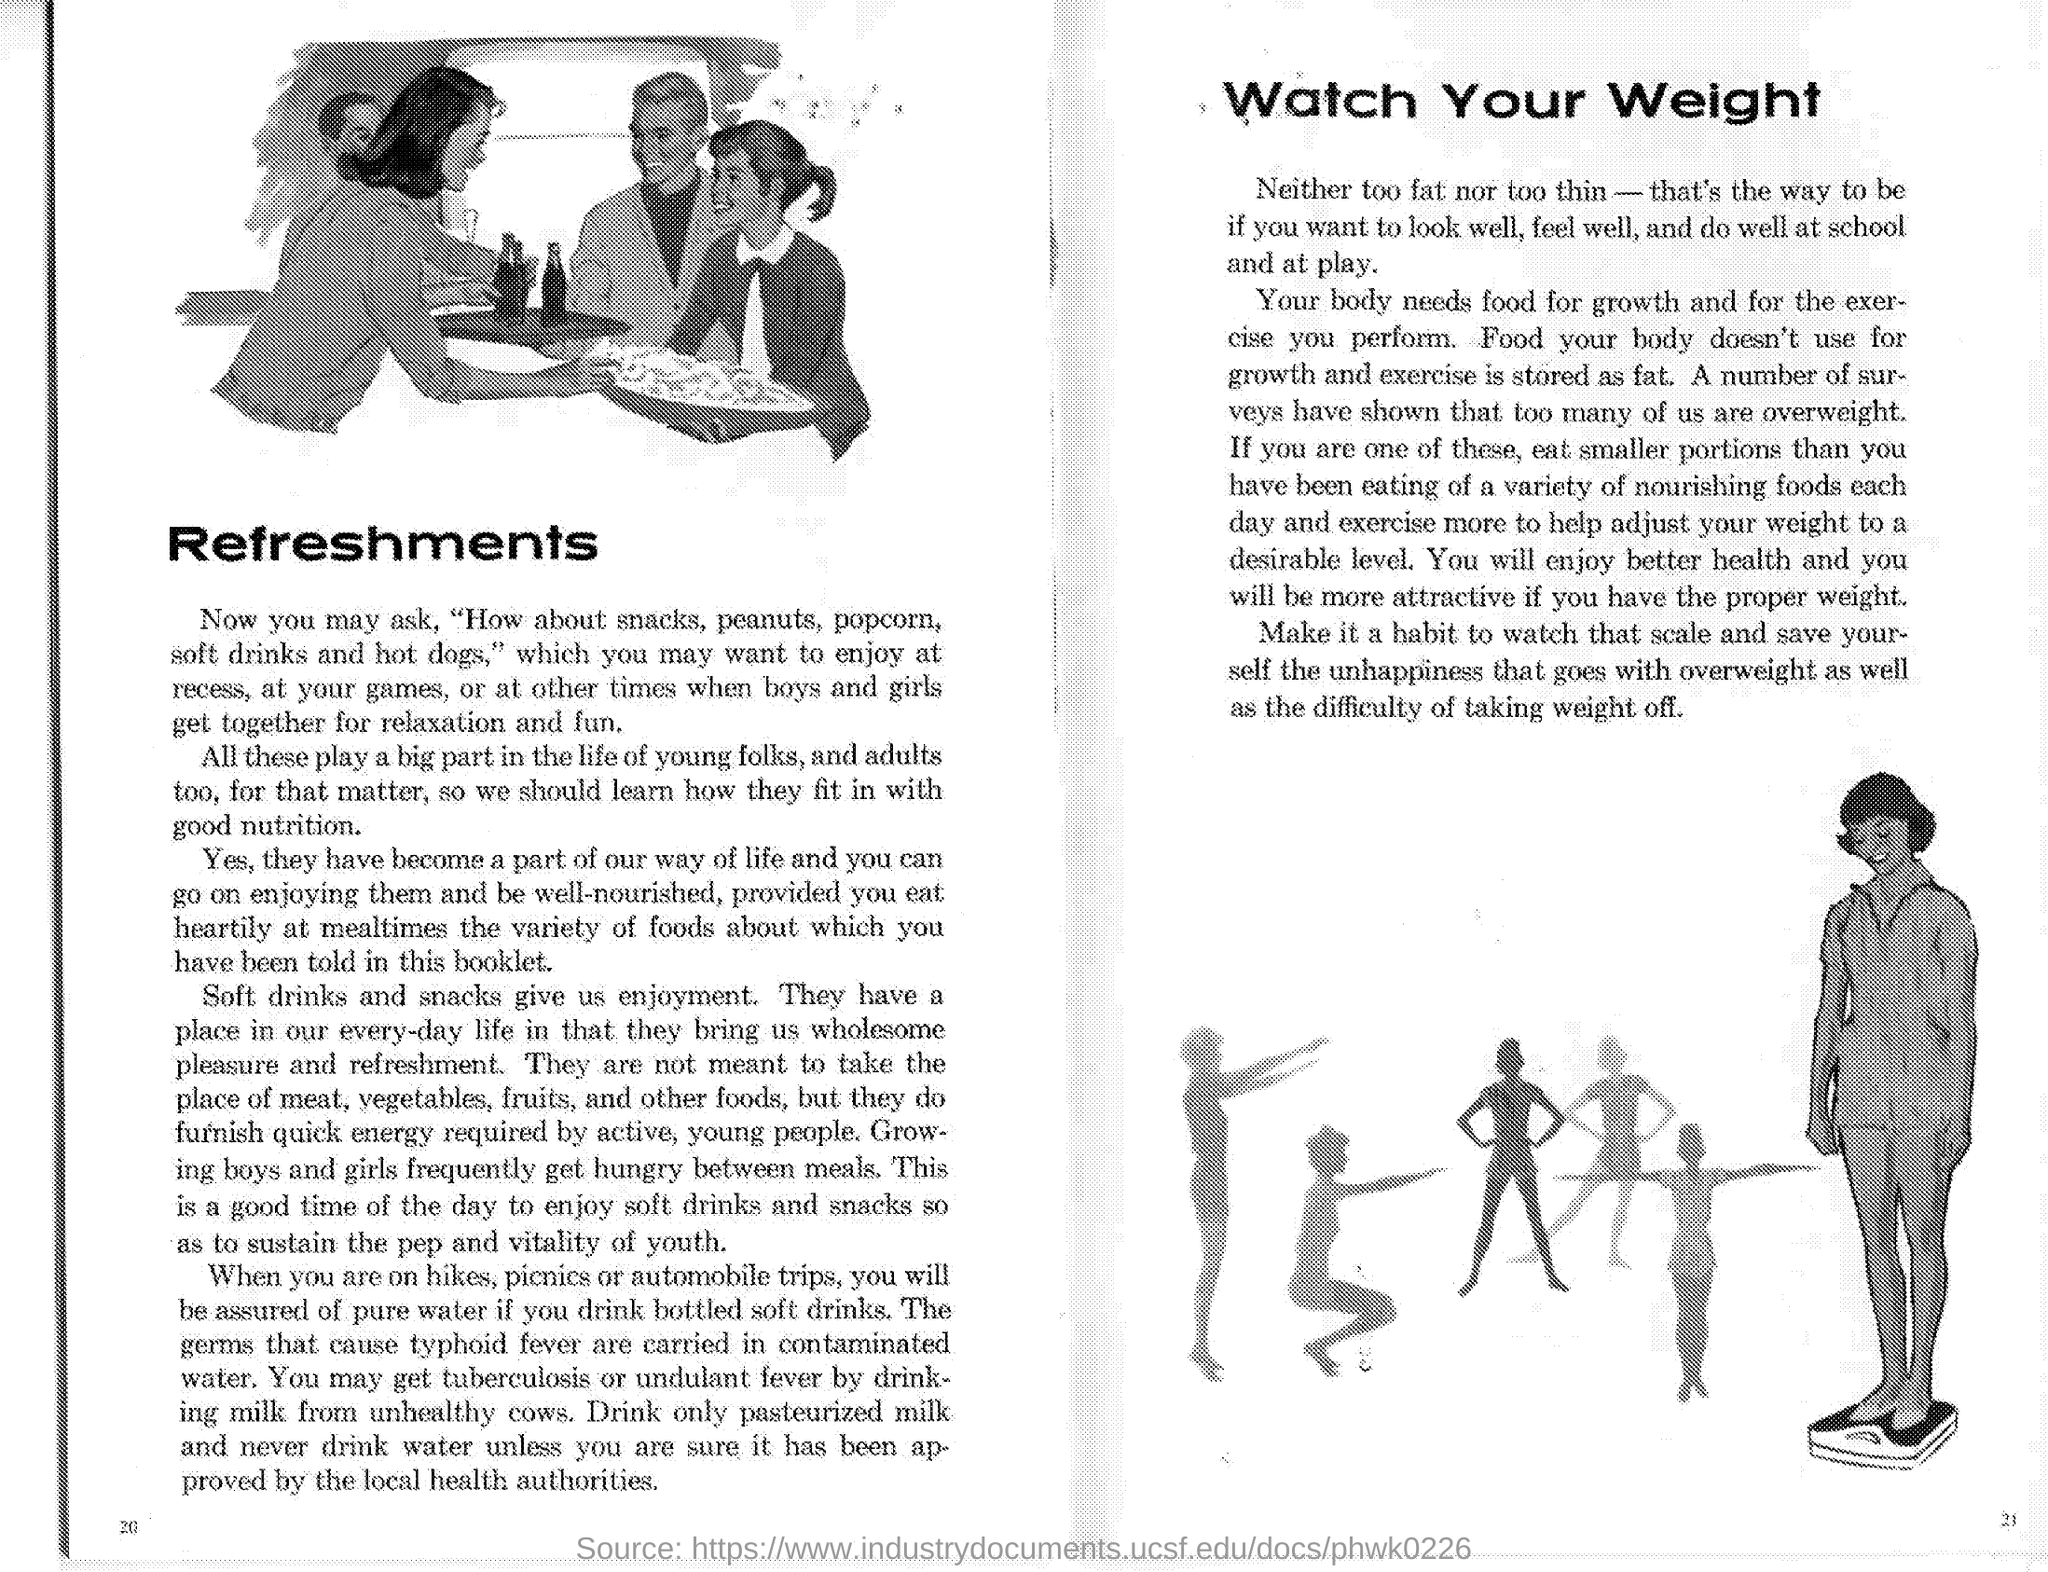What is the first side heading given?
Offer a very short reply. Refreshments. What "gives us enjoyment" as mentioned under "Refreshments"?
Offer a terse response. SOFT DRINKS AND SNACKS. According to the article drinking water should  be "approved by" whom?
Your response must be concise. Local health authorities. What is the second side heading given?
Your answer should be compact. Watch Your Weight. "Food your body doesn't use for growth and exercise is stored" as what?
Give a very brief answer. Fat. "Too many of us are" in which state as "number of surveys have shown"?
Your answer should be very brief. Overweight. According to the article "You will enjoy better health and you will be more attractive if you have" what?
Give a very brief answer. The proper weight. 